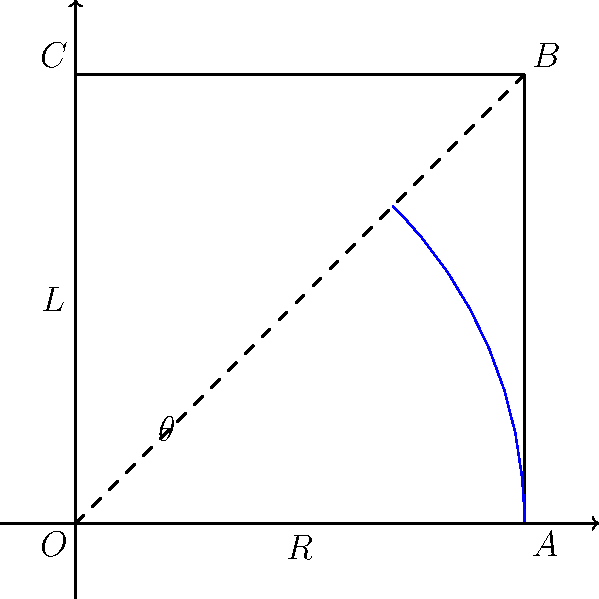As you review the latest luxury sports car for your magazine, you need to calculate its turning radius. The car has a wheelbase of 2.8 meters and a maximum steering angle of 35 degrees. Assuming the car is making a turn at its maximum steering angle, what is its turning radius (rounded to the nearest tenth of a meter)? To calculate the turning radius of the car, we'll use the formula:

$$R = \frac{L}{\sin(\theta)}$$

Where:
$R$ = turning radius
$L$ = wheelbase
$\theta$ = steering angle

Given:
$L = 2.8$ meters
$\theta = 35$ degrees

Step 1: Convert the angle to radians (although not necessary for most calculators):
$$35° \times \frac{\pi}{180°} \approx 0.6109 \text{ radians}$$

Step 2: Apply the formula:
$$R = \frac{2.8}{\sin(35°)}$$

Step 3: Calculate:
$$R \approx \frac{2.8}{0.5736} \approx 4.8819 \text{ meters}$$

Step 4: Round to the nearest tenth:
$$R \approx 4.9 \text{ meters}$$

This turning radius represents the radius of the circular path that the center of the rear axle would follow during a turn at maximum steering angle.
Answer: 4.9 meters 